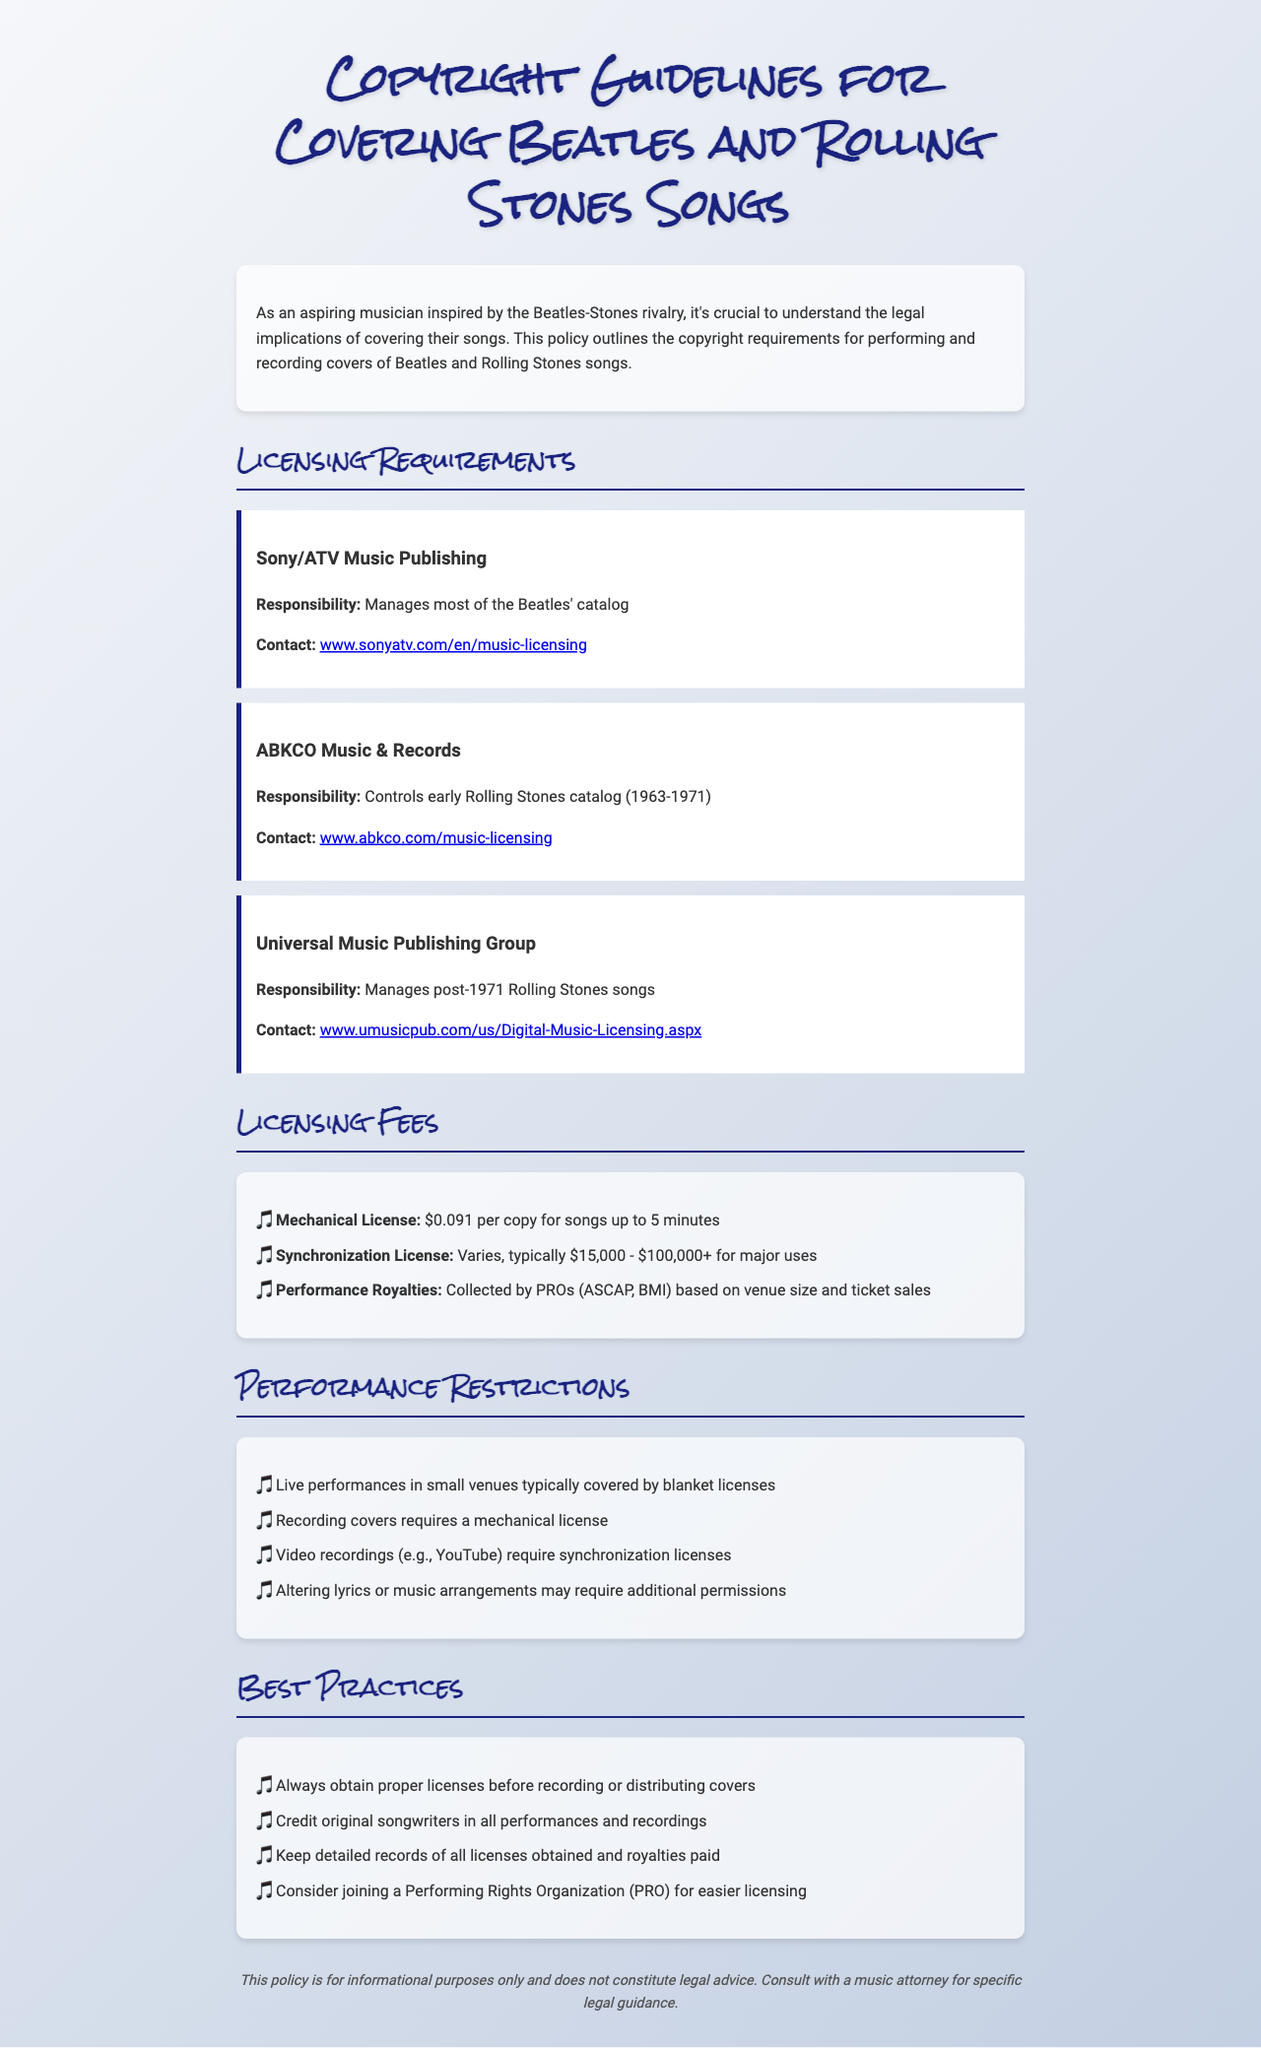What is the responsibility of Sony/ATV Music Publishing? Sony/ATV Music Publishing manages most of the Beatles' catalog.
Answer: Manages most of the Beatles' catalog What is the contact website for ABKCO Music & Records? The document provides a specific contact link for ABKCO Music & Records.
Answer: www.abkco.com/music-licensing What is the mechanical license fee for songs up to 5 minutes? The document specifies the mechanical license fee for songs within a certain length.
Answer: $0.091 per copy What is the typical range for synchronization licenses? The document includes a range for synchronization license fees for major uses.
Answer: $15,000 - $100,000+ How are performance royalties collected? The document explains how performance royalties are obtained by PROs.
Answer: Collected by PROs What is required for live performances in small venues? The document states the licensing requirement for a specific type of live performance.
Answer: Typically covered by blanket licenses Do you need a mechanical license for recording covers? The document outlines the licensing requirements for recording covers.
Answer: Yes What should you do before recording or distributing covers? The document mentions a best practice concerning licensing prior to recording.
Answer: Obtain proper licenses What type of organization should you consider joining for easier licensing? The document suggests a type of organization to join that aids in licensing.
Answer: Performing Rights Organization (PRO) 